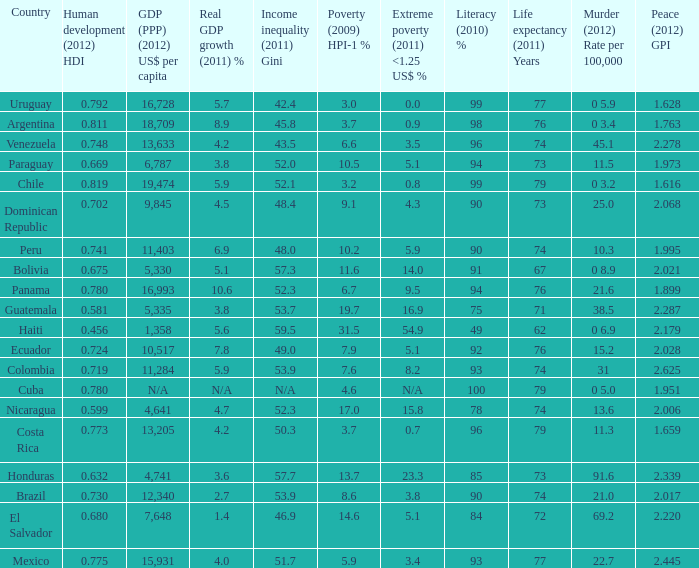What is the total poverty (2009) HPI-1 % when the extreme poverty (2011) <1.25 US$ % of 16.9, and the human development (2012) HDI is less than 0.581? None. 